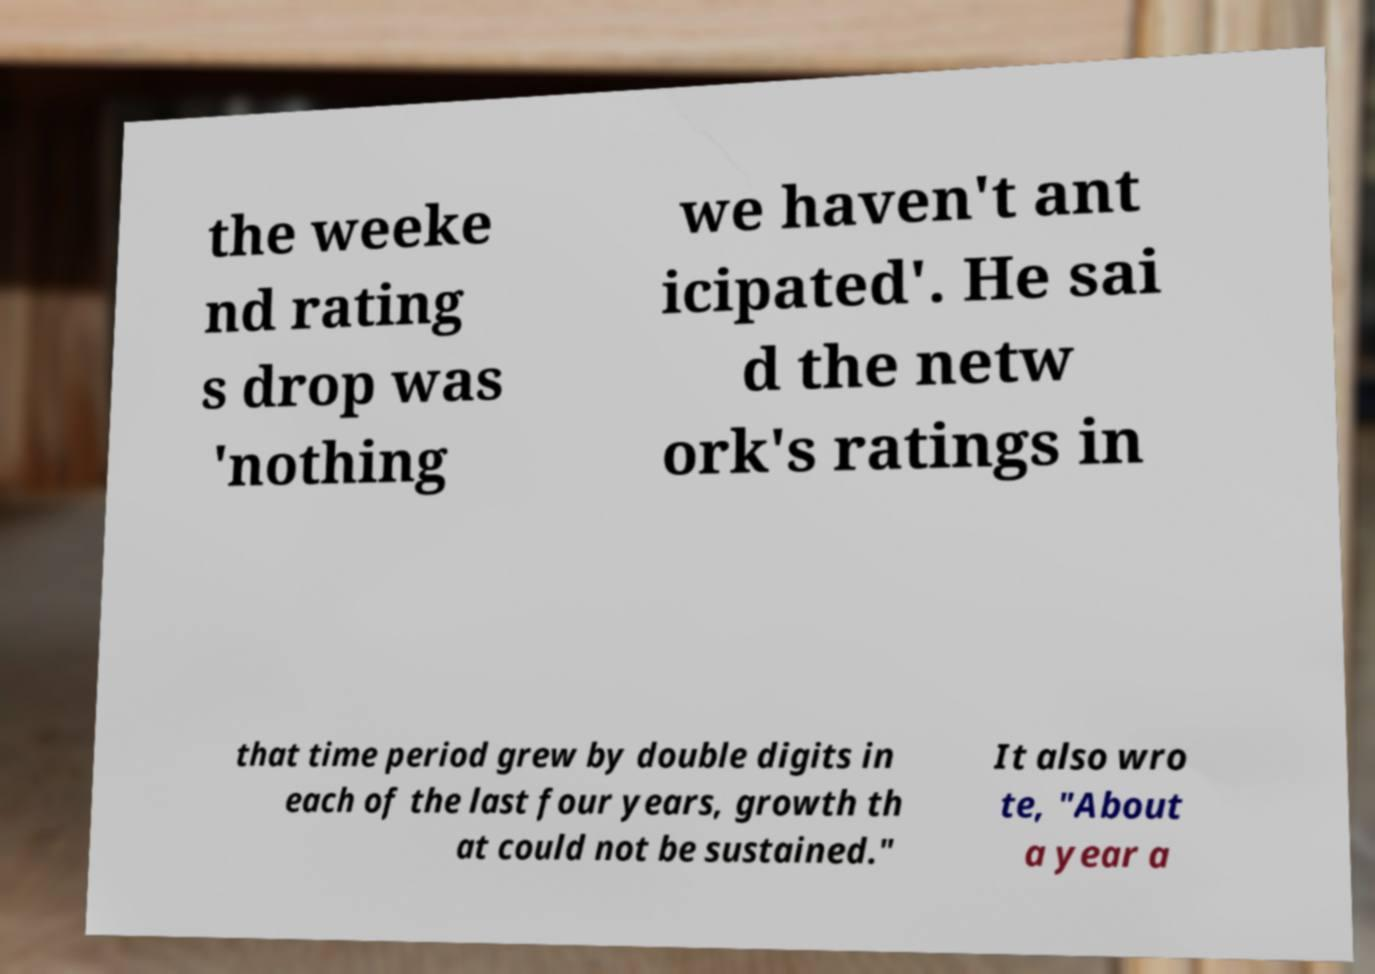Could you assist in decoding the text presented in this image and type it out clearly? the weeke nd rating s drop was 'nothing we haven't ant icipated'. He sai d the netw ork's ratings in that time period grew by double digits in each of the last four years, growth th at could not be sustained." It also wro te, "About a year a 